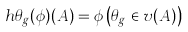Convert formula to latex. <formula><loc_0><loc_0><loc_500><loc_500>\ h { \theta } _ { g } ( \phi ) ( A ) = \phi \left ( \theta _ { g } \in v ( A ) \right )</formula> 